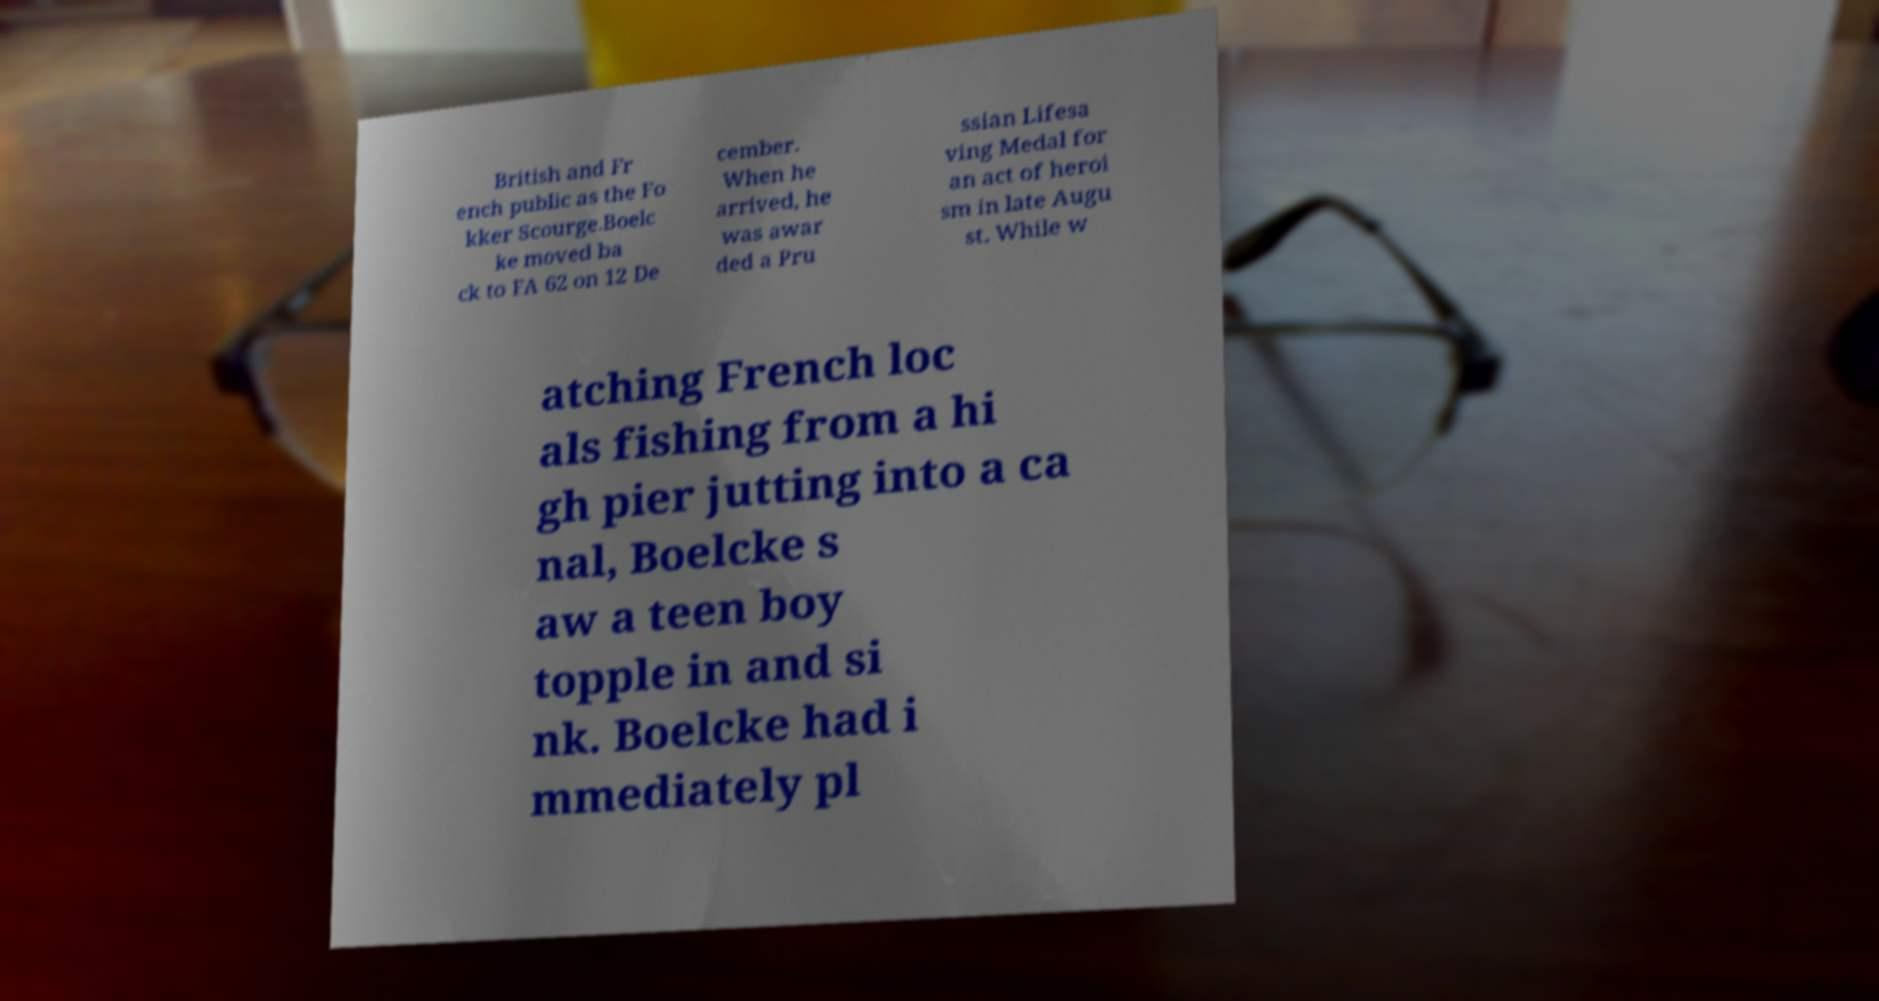Could you assist in decoding the text presented in this image and type it out clearly? British and Fr ench public as the Fo kker Scourge.Boelc ke moved ba ck to FA 62 on 12 De cember. When he arrived, he was awar ded a Pru ssian Lifesa ving Medal for an act of heroi sm in late Augu st. While w atching French loc als fishing from a hi gh pier jutting into a ca nal, Boelcke s aw a teen boy topple in and si nk. Boelcke had i mmediately pl 